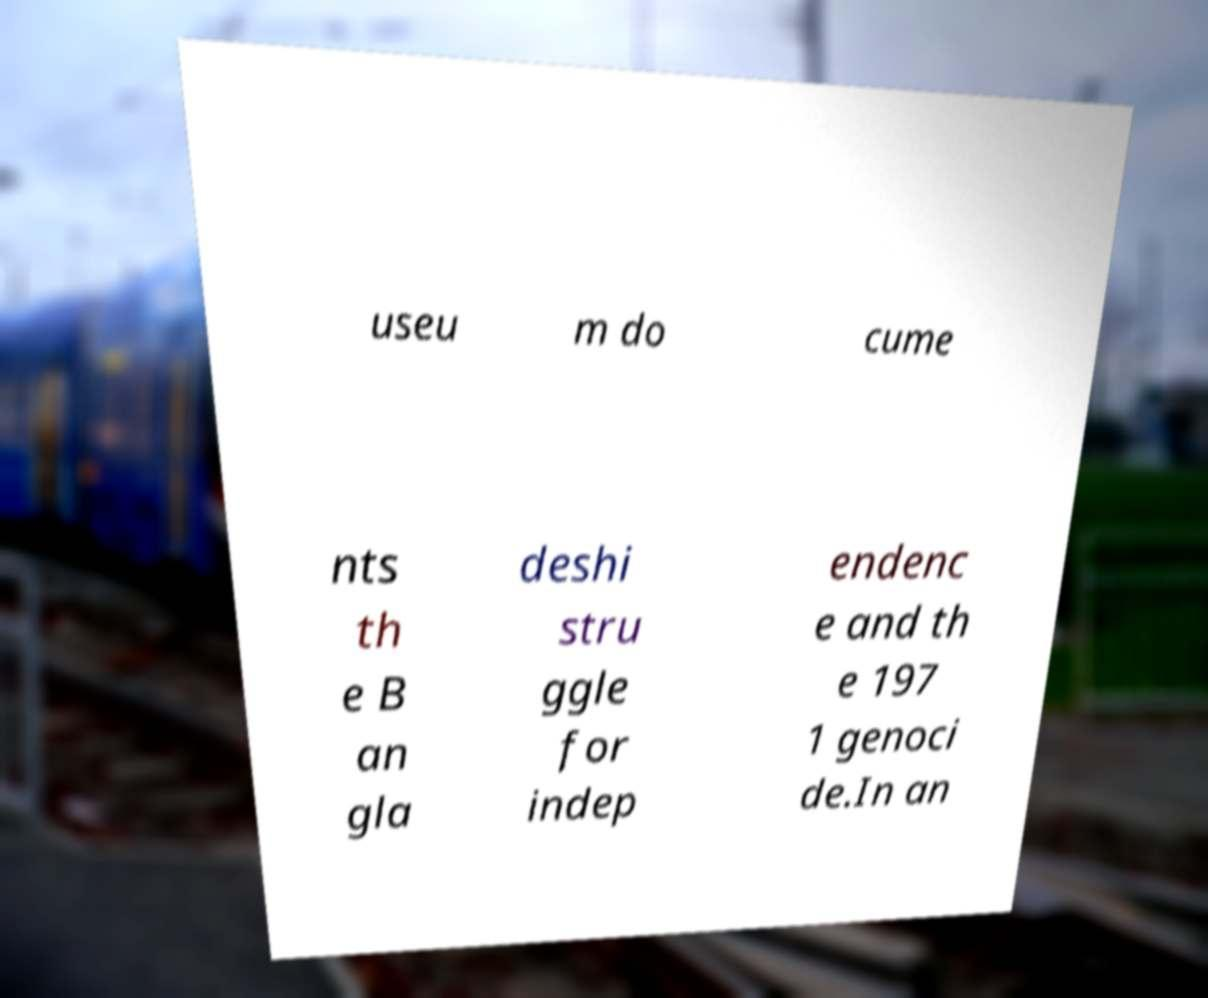Could you extract and type out the text from this image? useu m do cume nts th e B an gla deshi stru ggle for indep endenc e and th e 197 1 genoci de.In an 